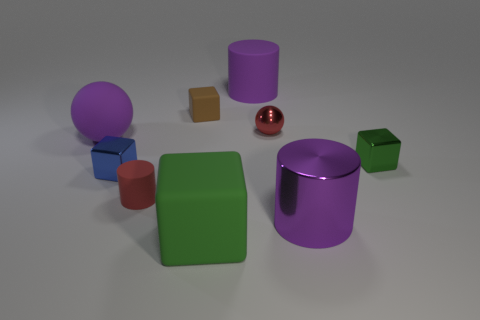There is a brown thing that is the same size as the red metal sphere; what is it made of?
Provide a short and direct response. Rubber. What size is the blue cube that is left of the red ball?
Your answer should be very brief. Small. What is the size of the green rubber object?
Give a very brief answer. Large. There is a blue cube; is its size the same as the matte block that is in front of the large ball?
Make the answer very short. No. There is a big rubber thing that is behind the purple matte thing that is left of the blue metallic object; what is its color?
Offer a very short reply. Purple. Are there an equal number of big rubber cylinders that are on the left side of the tiny brown thing and matte spheres that are to the right of the small red shiny thing?
Provide a succinct answer. Yes. Is the purple cylinder that is behind the brown thing made of the same material as the small blue object?
Provide a short and direct response. No. What color is the tiny block that is in front of the small brown object and on the left side of the green matte object?
Your response must be concise. Blue. What number of large matte balls are in front of the green object in front of the small blue block?
Your answer should be very brief. 0. What is the material of the large object that is the same shape as the small brown thing?
Ensure brevity in your answer.  Rubber. 